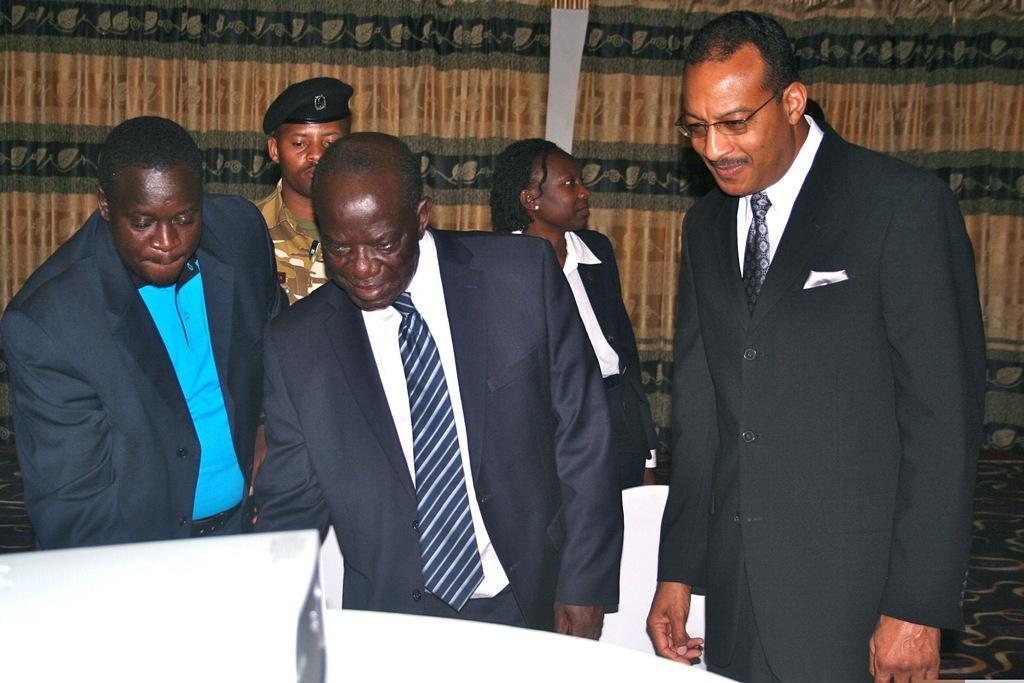How would you summarize this image in a sentence or two? This picture shows few people standing and we see a man wore a cap on his head and we see all the people wore coats and a man wore spectacles on his face and we see a curtain on the back. 